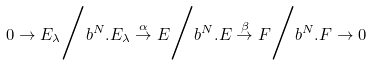Convert formula to latex. <formula><loc_0><loc_0><loc_500><loc_500>0 \to E _ { \lambda } \Big / b ^ { N } . E _ { \lambda } \overset { \alpha } { \to } E \Big / b ^ { N } . E \overset { \beta } { \to } F \Big / b ^ { N } . F \to 0</formula> 